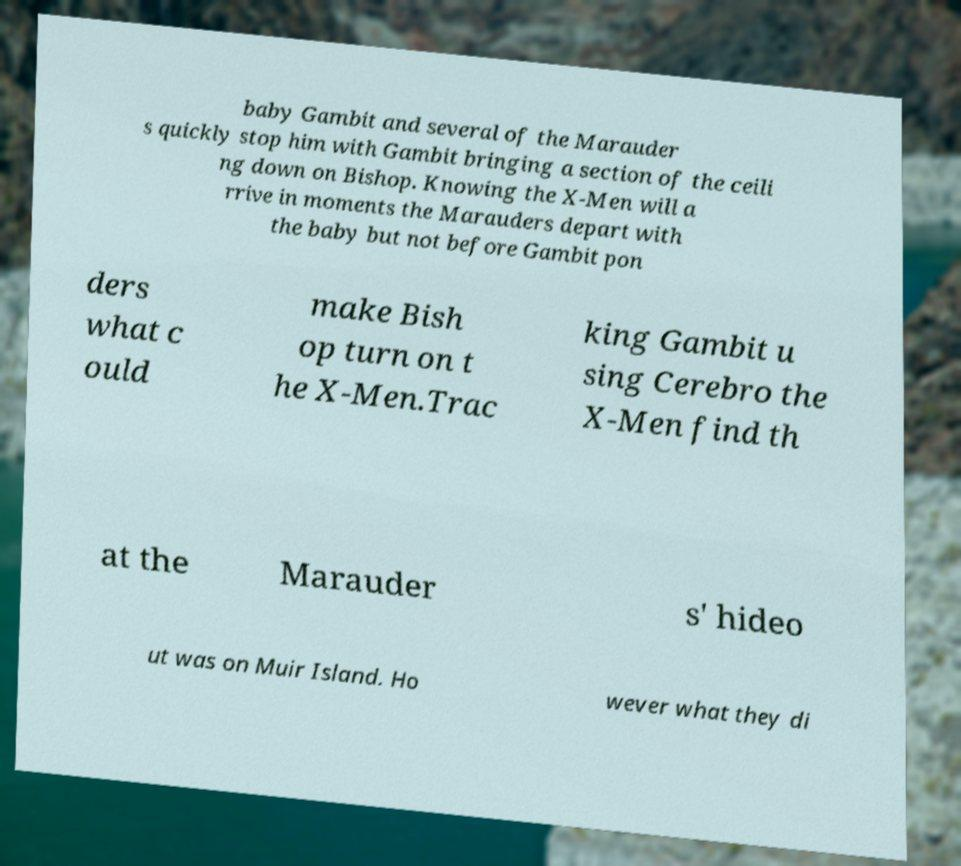Can you accurately transcribe the text from the provided image for me? baby Gambit and several of the Marauder s quickly stop him with Gambit bringing a section of the ceili ng down on Bishop. Knowing the X-Men will a rrive in moments the Marauders depart with the baby but not before Gambit pon ders what c ould make Bish op turn on t he X-Men.Trac king Gambit u sing Cerebro the X-Men find th at the Marauder s' hideo ut was on Muir Island. Ho wever what they di 